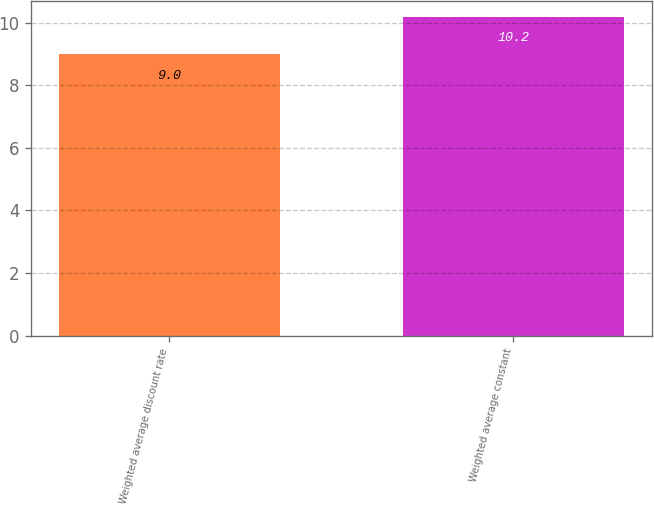Convert chart. <chart><loc_0><loc_0><loc_500><loc_500><bar_chart><fcel>Weighted average discount rate<fcel>Weighted average constant<nl><fcel>9<fcel>10.2<nl></chart> 